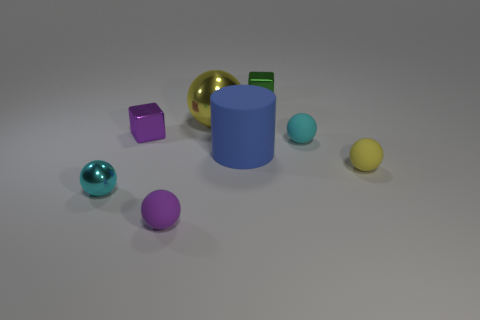Subtract all yellow spheres. How many spheres are left? 3 Subtract all yellow shiny balls. How many balls are left? 4 Add 1 big blue rubber cylinders. How many objects exist? 9 Subtract all green balls. Subtract all gray cylinders. How many balls are left? 5 Subtract all cubes. How many objects are left? 6 Add 7 green cubes. How many green cubes are left? 8 Add 6 purple metal balls. How many purple metal balls exist? 6 Subtract 0 cyan blocks. How many objects are left? 8 Subtract all tiny cyan spheres. Subtract all yellow metal spheres. How many objects are left? 5 